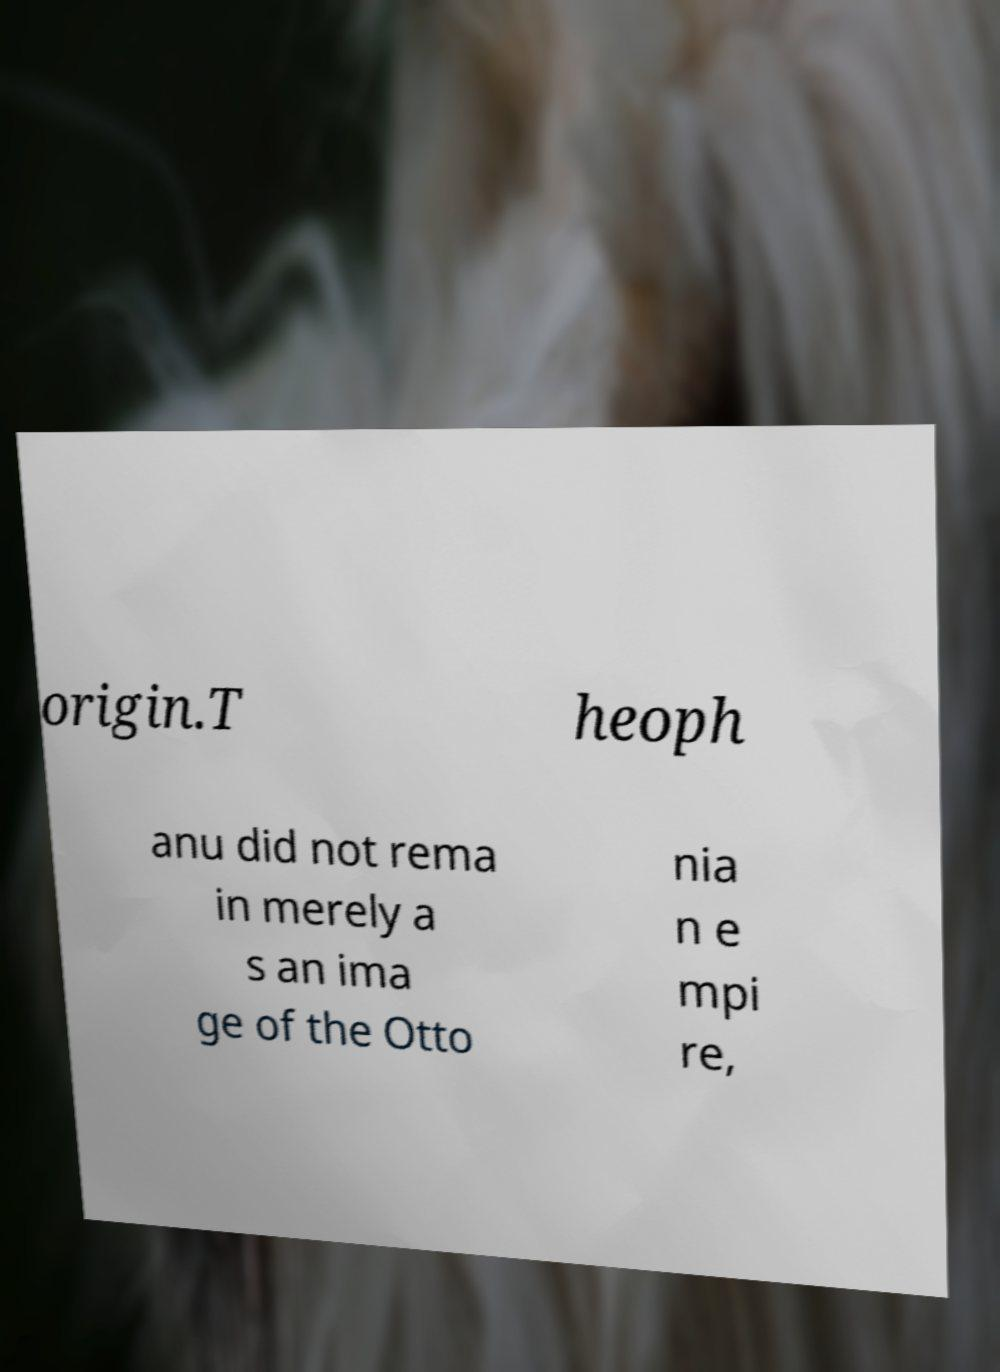What messages or text are displayed in this image? I need them in a readable, typed format. origin.T heoph anu did not rema in merely a s an ima ge of the Otto nia n e mpi re, 